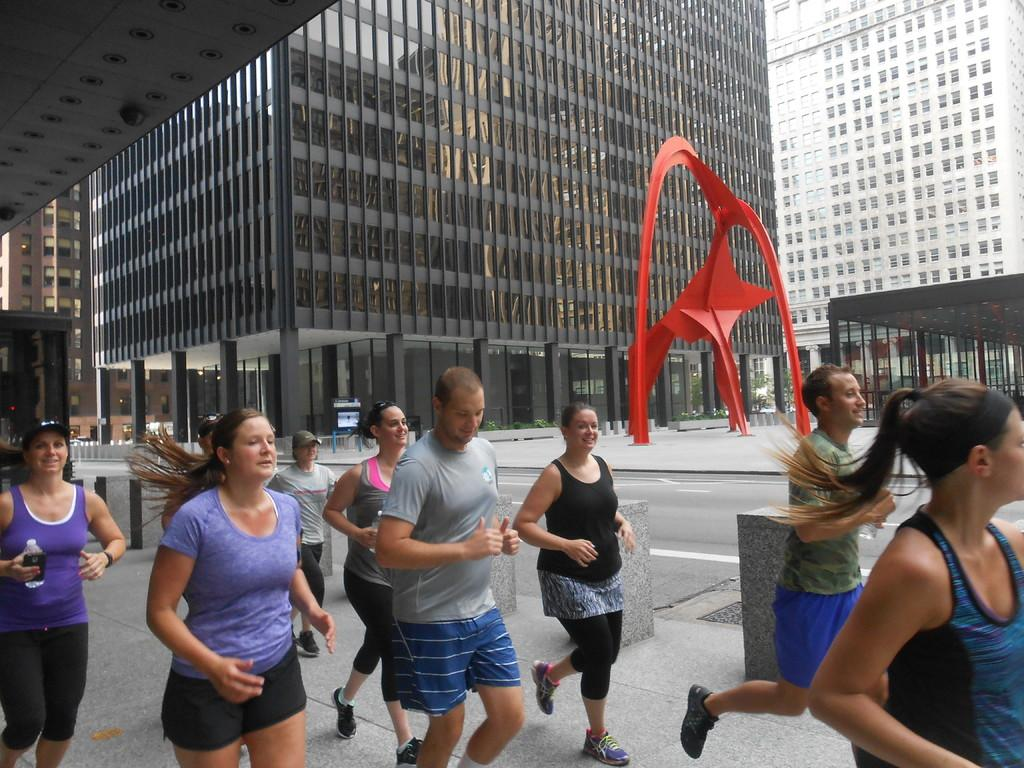Who or what can be seen in the image? There are people in the image. What is the main feature of the landscape in the image? There is a road in the image. What type of structures can be seen in the background? There are buildings with windows in the background of the image. What type of brick is being used by the people in the image? There is no mention of brick in the image. --- Facts: 1. There is a person in the image. 2. The person is wearing a hat. 3. The person is holding a book. 4. The book has a title on the cover. 5. The background of the image is a park. Absurd Topics: elephant, piano, ocean Conversation: Who or what can be seen in the image? There is a person in the image. What is the person wearing in the image? The person is wearing a hat in the image. What is the person holding in the image? The person is holding a book in the image. What can be seen on the cover of the book? The book has a title on the cover in the image. What is the background of the image? The background of the image is a park. Reasoning: Let's think step by step in order to produce the conversation. We start by identifying the main subject in the image, which is the person. Then, we describe the person's attire and what they are holding. Next, we focus on the book and mention the title on the cover. Finally, we describe the background of the image, which is a park. Each question is designed to elicit a specific detail about the image that is known from the provided facts. Absurd Question/Answer: Can you hear the elephant playing the piano in the image? There is no mention of an elephant, a piano, or an ocean in the image. 